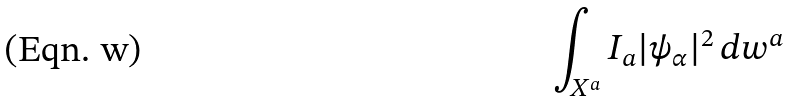Convert formula to latex. <formula><loc_0><loc_0><loc_500><loc_500>\int _ { X ^ { a } } I _ { a } | \psi _ { \alpha } | ^ { 2 } \, d w ^ { a }</formula> 